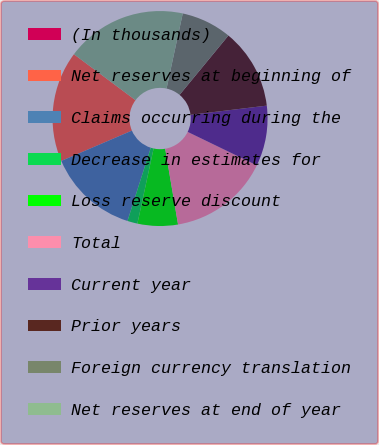Convert chart. <chart><loc_0><loc_0><loc_500><loc_500><pie_chart><fcel>(In thousands)<fcel>Net reserves at beginning of<fcel>Claims occurring during the<fcel>Decrease in estimates for<fcel>Loss reserve discount<fcel>Total<fcel>Current year<fcel>Prior years<fcel>Foreign currency translation<fcel>Net reserves at end of year<nl><fcel>0.0%<fcel>16.66%<fcel>13.64%<fcel>1.52%<fcel>6.06%<fcel>15.15%<fcel>9.09%<fcel>12.12%<fcel>7.58%<fcel>18.18%<nl></chart> 